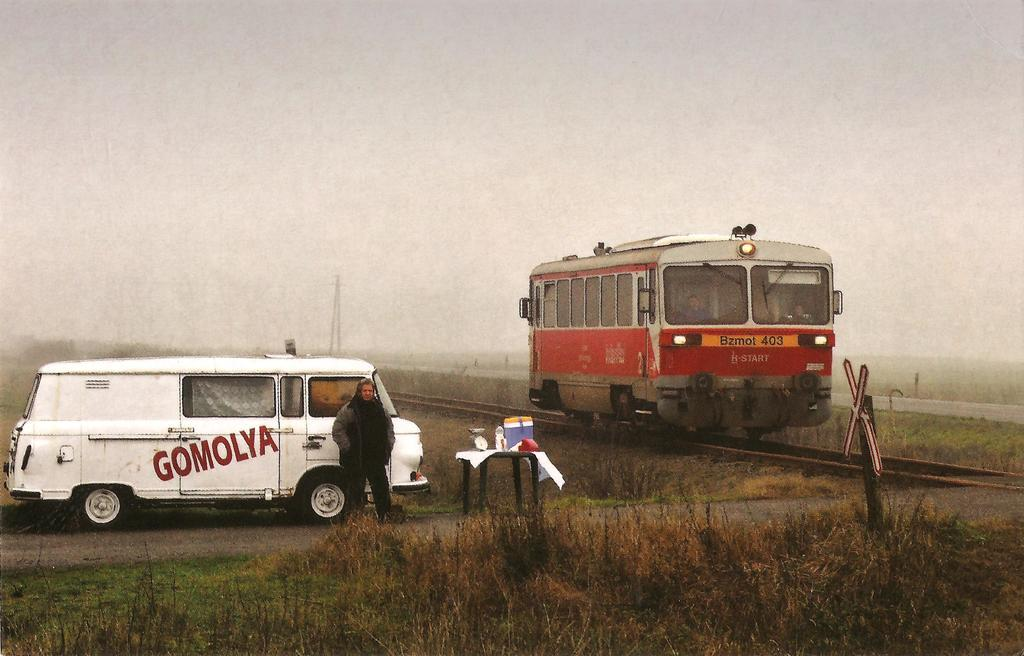What is the main subject of the image? The main subject of the image is a train. What is the train doing in the image? The train is moving on a railway track. Can you describe the man in the image? There is a man standing behind the train. What else can be seen in the image besides the train and the man? There is a vehicle and grass visible in the image. What is the name of the person sitting on the train in the image? There is no person sitting on the train in the image; only a man is standing behind the train. What time of day is it in the image, considering the presence of the afternoon sun? The facts provided do not mention the time of day or the presence of the afternoon sun, so it cannot be determined from the image. 